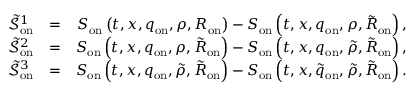Convert formula to latex. <formula><loc_0><loc_0><loc_500><loc_500>\begin{array} { r l r } { \tilde { \mathcal { S } } _ { o n } ^ { 1 } } & { = } & { S _ { o n } \left ( t , x , q _ { o n } , \rho , R _ { o n } \right ) - S _ { o n } \left ( t , x , q _ { o n } , \rho , \tilde { R } _ { o n } \right ) , } \\ { \tilde { \mathcal { S } } _ { o n } ^ { 2 } } & { = } & { S _ { o n } \left ( t , x , q _ { o n } , \rho , \tilde { R } _ { o n } \right ) - S _ { o n } \left ( t , x , q _ { o n } , \tilde { \rho } , \tilde { R } _ { o n } \right ) , } \\ { \tilde { \mathcal { S } } _ { o n } ^ { 3 } } & { = } & { S _ { o n } \left ( t , x , q _ { o n } , \tilde { \rho } , \tilde { R } _ { o n } \right ) - S _ { o n } \left ( t , x , \tilde { q } _ { o n } , \tilde { \rho } , \tilde { R } _ { o n } \right ) . } \end{array}</formula> 